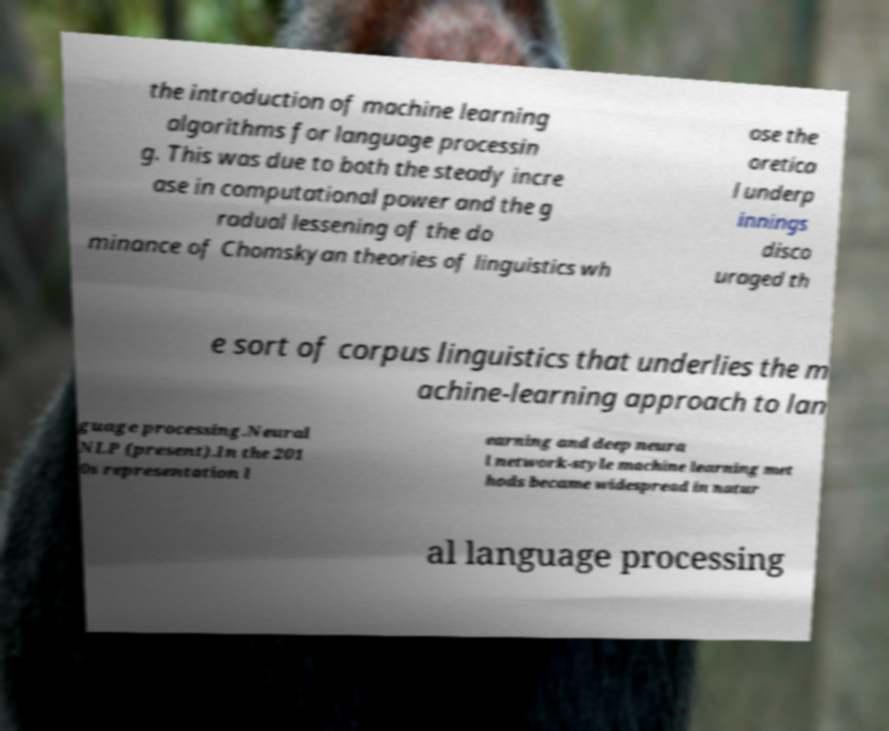Can you read and provide the text displayed in the image?This photo seems to have some interesting text. Can you extract and type it out for me? the introduction of machine learning algorithms for language processin g. This was due to both the steady incre ase in computational power and the g radual lessening of the do minance of Chomskyan theories of linguistics wh ose the oretica l underp innings disco uraged th e sort of corpus linguistics that underlies the m achine-learning approach to lan guage processing.Neural NLP (present).In the 201 0s representation l earning and deep neura l network-style machine learning met hods became widespread in natur al language processing 